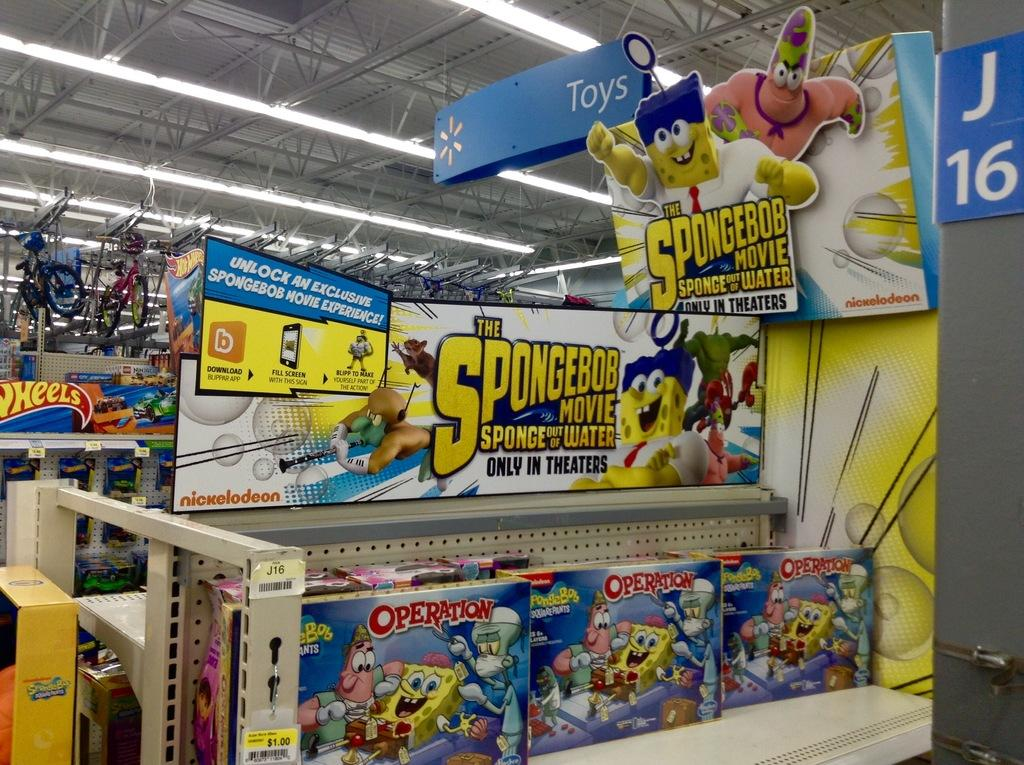Provide a one-sentence caption for the provided image. a store display featuring SpongeBob adverts and an Operation game toy on the shelf. 